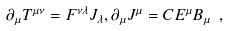<formula> <loc_0><loc_0><loc_500><loc_500>\partial _ { \mu } T ^ { \mu \nu } = F ^ { \nu \lambda } J _ { \lambda } , \partial _ { \mu } J ^ { \mu } = C E ^ { \mu } B _ { \mu } \ ,</formula> 